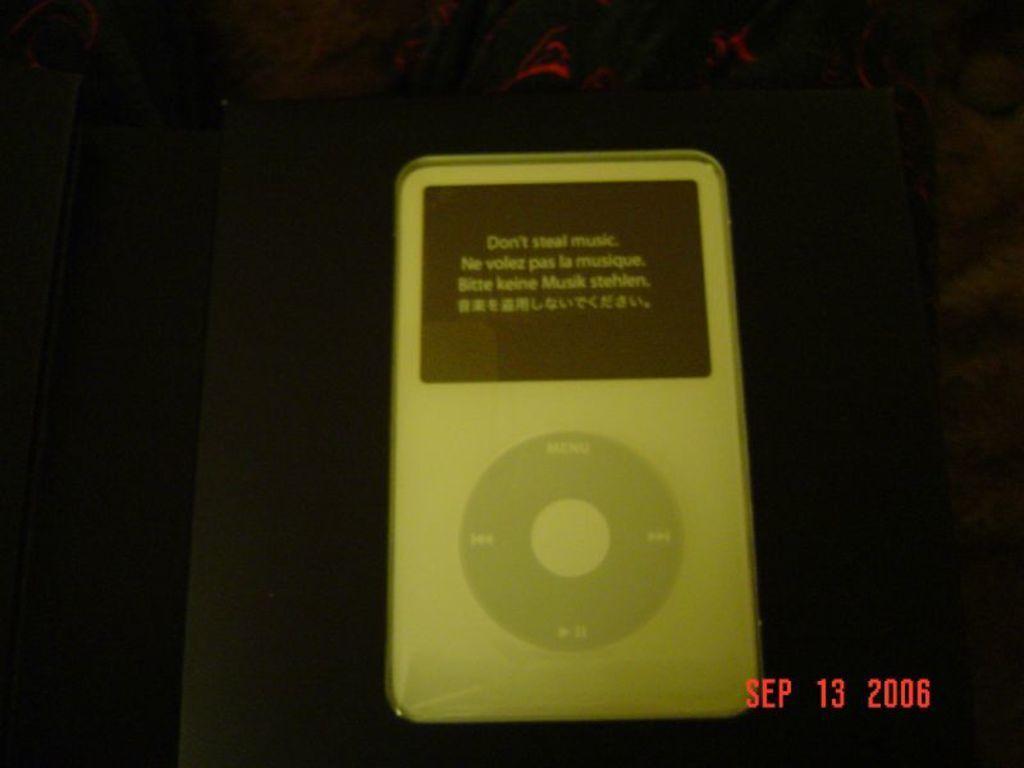Could you give a brief overview of what you see in this image? In this picture we can observe a picture of an Ipod on the black color box. This Ipod is in white color. We can observe red color words on the right side. In the background it is completely dark. 